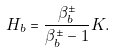<formula> <loc_0><loc_0><loc_500><loc_500>H _ { b } = \frac { \beta ^ { \pm } _ { b } } { \beta ^ { \pm } _ { b } - 1 } K .</formula> 